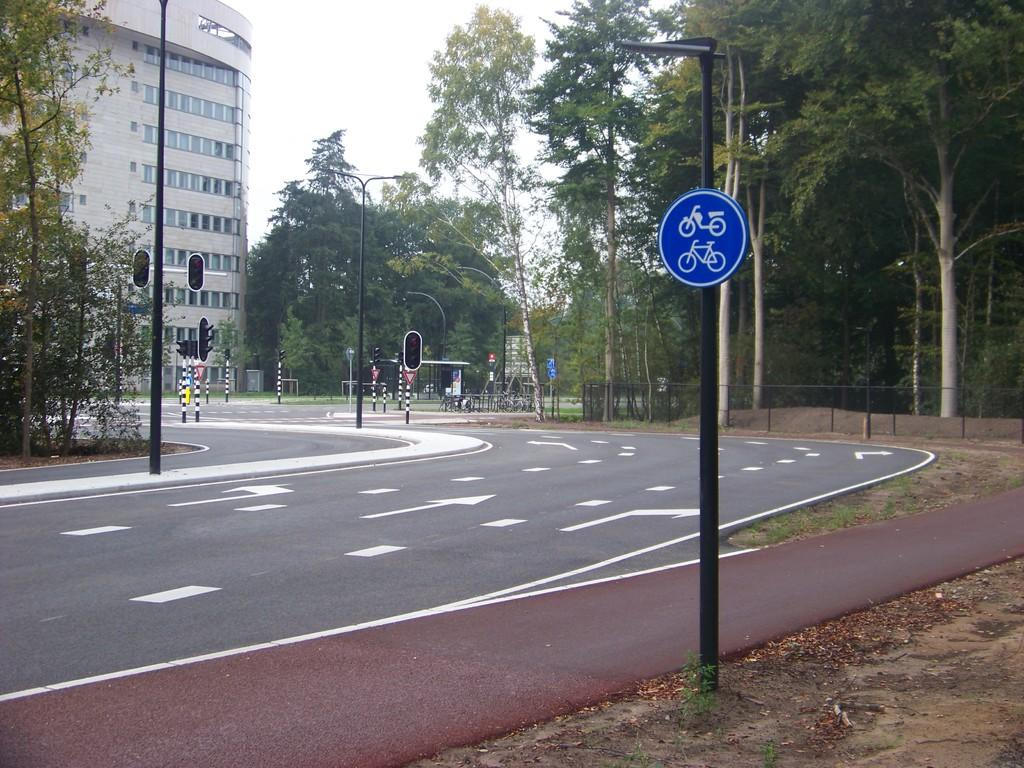What type of structure is visible in the image? There is a building in the image. What other natural elements can be seen in the image? There are trees in the image. What type of lighting is present in the image? There are pole lights in the image. Are there any additional features on the poles? Yes, there are sign boards and traffic signal lights on the poles in the image. How would you describe the weather in the image? The sky is cloudy in the image. What type of wine is being served at the battle scene in the image? There is no battle scene or wine present in the image; it features a building, trees, pole lights, sign boards, traffic signal lights, and a cloudy sky. 